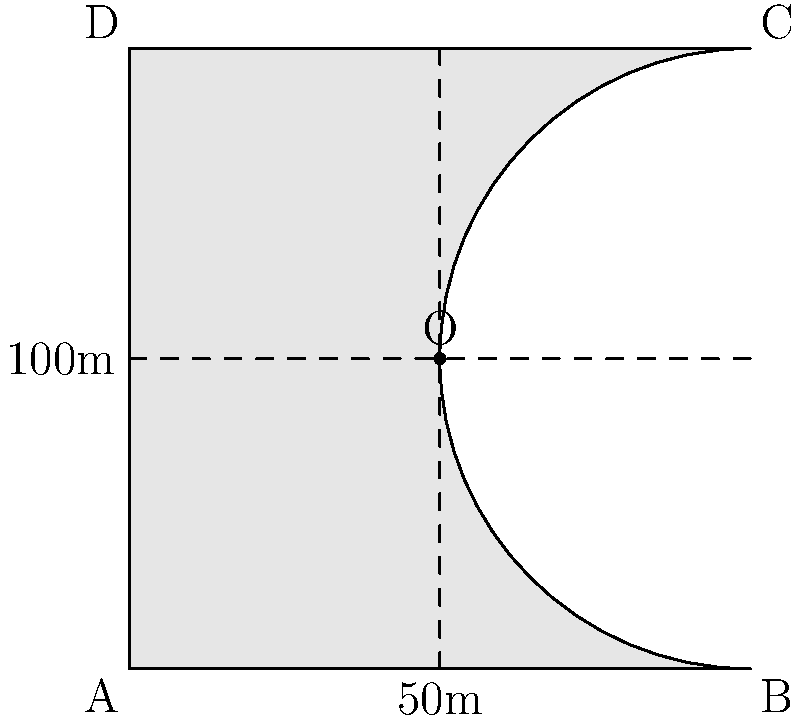A new women's football stadium is being designed with a rectangular main section and a semicircular end. The stadium's length is 100m, and its width is 100m. If the seating capacity is directly proportional to the stadium's area, how does the area of this design compare to a fully rectangular stadium of the same length and width? Let's approach this step-by-step:

1) The stadium consists of a rectangle (ABDO) and a semicircle (BCD).

2) Area of the rectangle:
   $A_{rectangle} = 100m \times 50m = 5000m^2$

3) Area of the semicircle:
   Radius = 50m (half the width)
   $A_{semicircle} = \frac{1}{2} \pi r^2 = \frac{1}{2} \pi (50m)^2 = 1250\pi m^2$

4) Total area of the stadium:
   $A_{total} = A_{rectangle} + A_{semicircle} = 5000m^2 + 1250\pi m^2$

5) Area of a fully rectangular stadium:
   $A_{rectangular} = 100m \times 100m = 10000m^2$

6) Difference in area:
   $\Delta A = A_{rectangular} - A_{total} = 10000m^2 - (5000m^2 + 1250\pi m^2)$
             $= 5000m^2 - 1250\pi m^2$
             $\approx 1073.45m^2$

7) Percentage difference:
   $\frac{\Delta A}{A_{rectangular}} \times 100\% = \frac{5000 - 1250\pi}{10000} \times 100\% \approx 10.73\%$
Answer: The semicircular design is approximately 10.73% smaller in area than a fully rectangular stadium. 